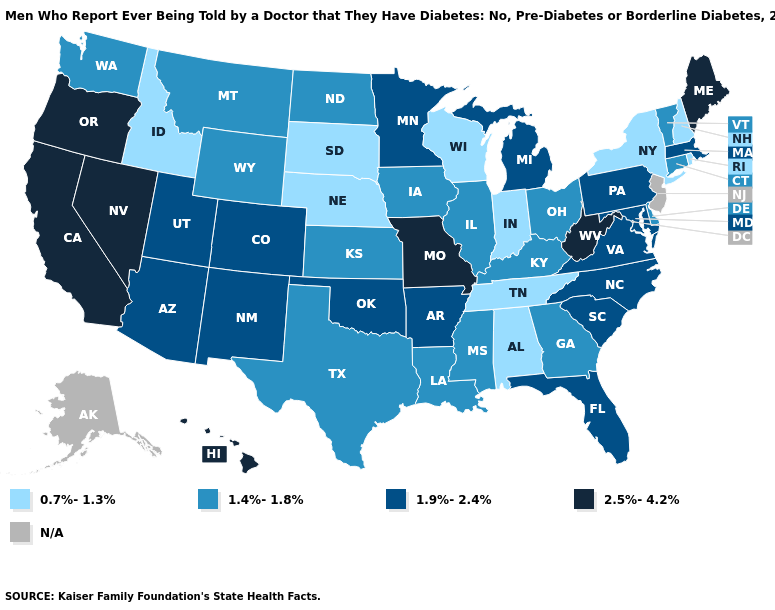What is the highest value in states that border California?
Give a very brief answer. 2.5%-4.2%. Name the states that have a value in the range 1.4%-1.8%?
Quick response, please. Connecticut, Delaware, Georgia, Illinois, Iowa, Kansas, Kentucky, Louisiana, Mississippi, Montana, North Dakota, Ohio, Texas, Vermont, Washington, Wyoming. Does the first symbol in the legend represent the smallest category?
Keep it brief. Yes. Name the states that have a value in the range 1.9%-2.4%?
Give a very brief answer. Arizona, Arkansas, Colorado, Florida, Maryland, Massachusetts, Michigan, Minnesota, New Mexico, North Carolina, Oklahoma, Pennsylvania, South Carolina, Utah, Virginia. Name the states that have a value in the range 2.5%-4.2%?
Keep it brief. California, Hawaii, Maine, Missouri, Nevada, Oregon, West Virginia. Name the states that have a value in the range 1.4%-1.8%?
Concise answer only. Connecticut, Delaware, Georgia, Illinois, Iowa, Kansas, Kentucky, Louisiana, Mississippi, Montana, North Dakota, Ohio, Texas, Vermont, Washington, Wyoming. Among the states that border Ohio , which have the lowest value?
Quick response, please. Indiana. Does Indiana have the highest value in the MidWest?
Short answer required. No. Which states have the lowest value in the West?
Concise answer only. Idaho. Name the states that have a value in the range 1.9%-2.4%?
Keep it brief. Arizona, Arkansas, Colorado, Florida, Maryland, Massachusetts, Michigan, Minnesota, New Mexico, North Carolina, Oklahoma, Pennsylvania, South Carolina, Utah, Virginia. What is the value of Massachusetts?
Answer briefly. 1.9%-2.4%. Does Kansas have the lowest value in the MidWest?
Concise answer only. No. Does South Dakota have the highest value in the MidWest?
Concise answer only. No. 